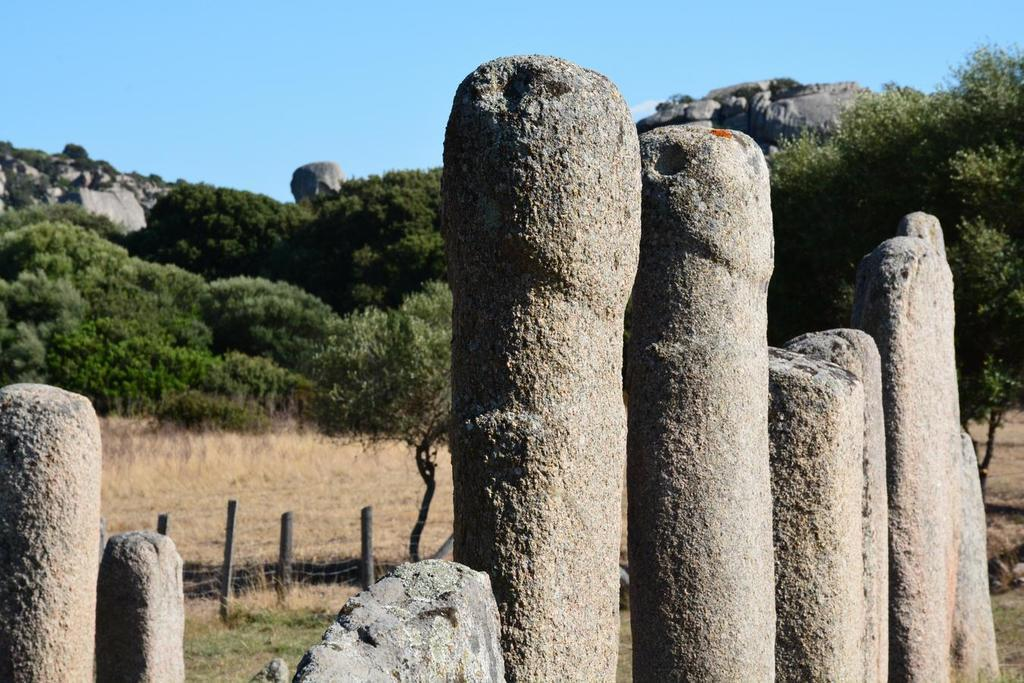What can be seen in the foreground of the image? There are poles in the foreground of the image. What is visible in the background of the image? There are trees, a fence, grass, rocks, and the sky in the background of the image. Can you describe the vegetation in the image? There are trees and grass visible in the image. What type of natural feature can be seen in the background of the image? There are rocks in the background of the image. How does the tree in the image attack the poles? There is no tree present in the image that could attack the poles. What happens when the tree smashes into the fence in the image? There is no tree smashing into the fence in the image, as there is no tree present. 